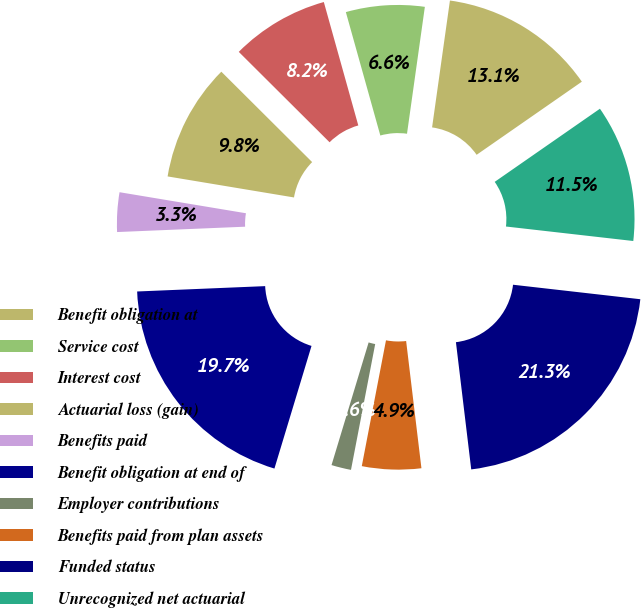<chart> <loc_0><loc_0><loc_500><loc_500><pie_chart><fcel>Benefit obligation at<fcel>Service cost<fcel>Interest cost<fcel>Actuarial loss (gain)<fcel>Benefits paid<fcel>Benefit obligation at end of<fcel>Employer contributions<fcel>Benefits paid from plan assets<fcel>Funded status<fcel>Unrecognized net actuarial<nl><fcel>13.11%<fcel>6.56%<fcel>8.2%<fcel>9.84%<fcel>3.29%<fcel>19.66%<fcel>1.65%<fcel>4.93%<fcel>21.29%<fcel>11.47%<nl></chart> 